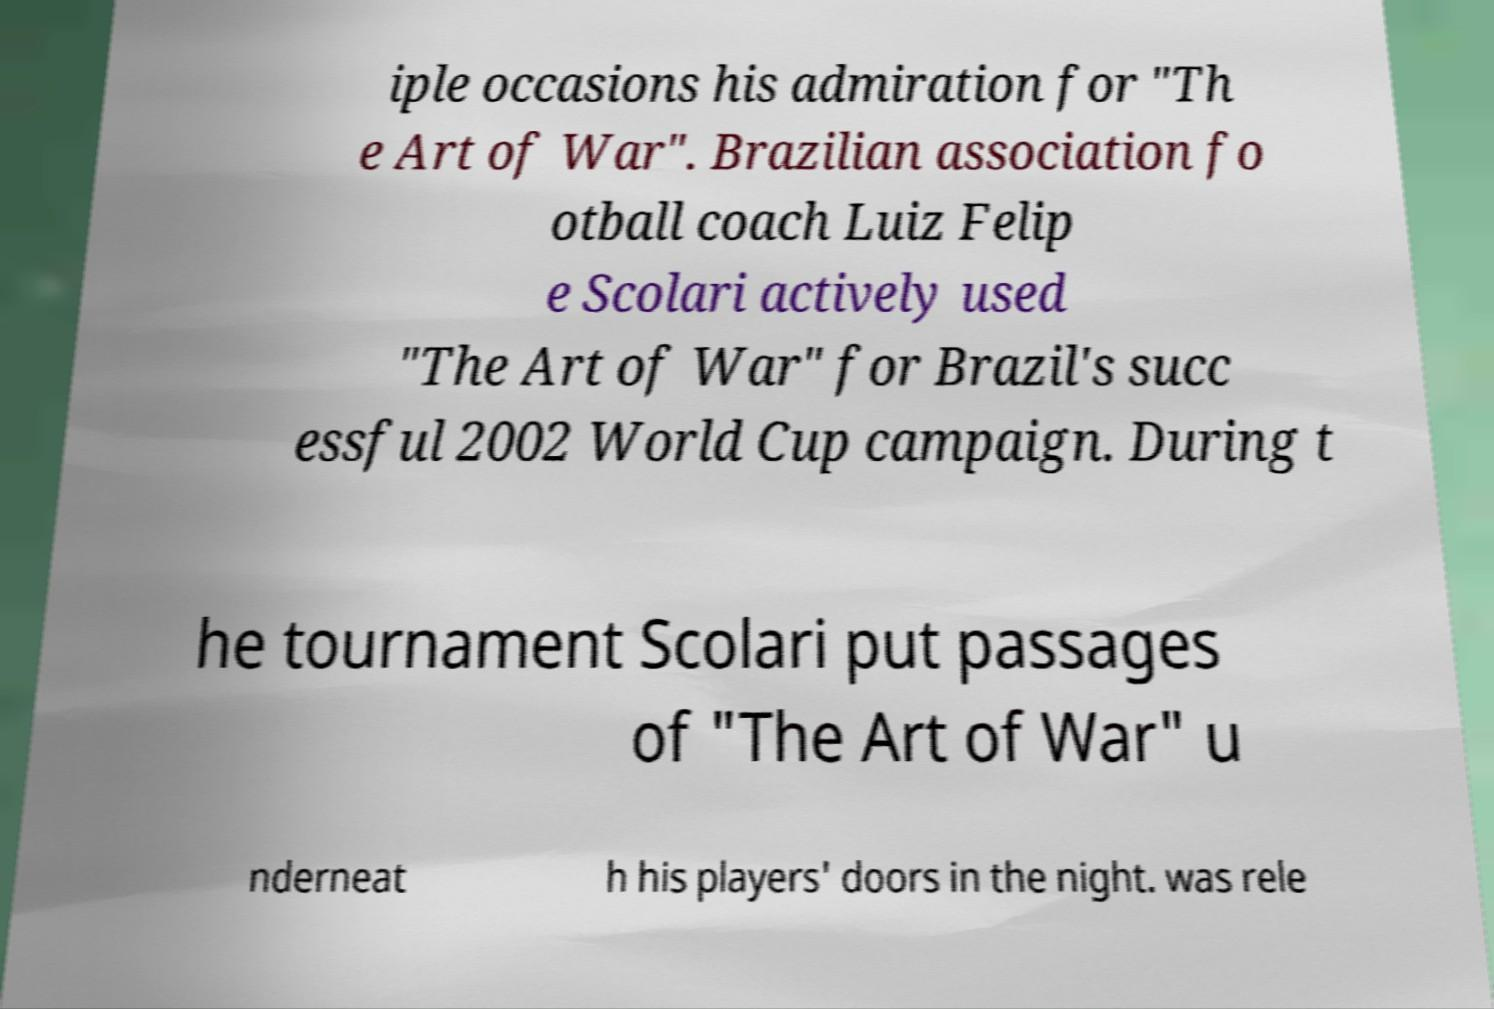Could you extract and type out the text from this image? iple occasions his admiration for "Th e Art of War". Brazilian association fo otball coach Luiz Felip e Scolari actively used "The Art of War" for Brazil's succ essful 2002 World Cup campaign. During t he tournament Scolari put passages of "The Art of War" u nderneat h his players' doors in the night. was rele 